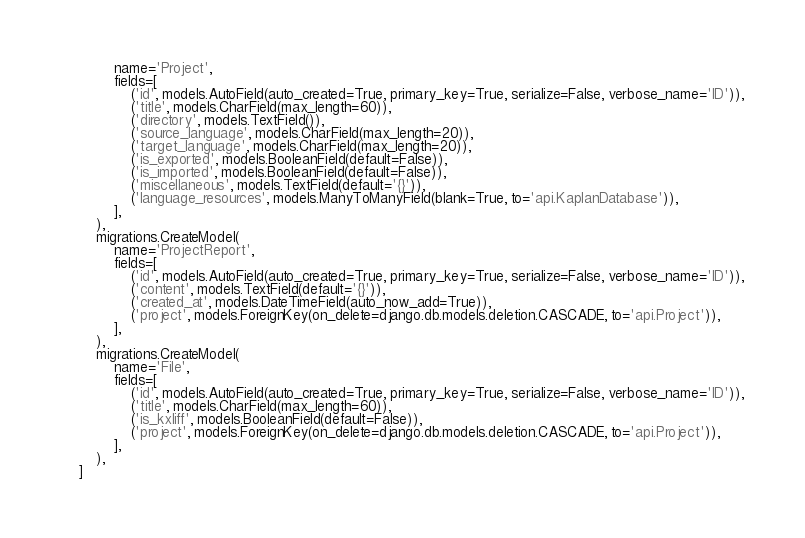<code> <loc_0><loc_0><loc_500><loc_500><_Python_>            name='Project',
            fields=[
                ('id', models.AutoField(auto_created=True, primary_key=True, serialize=False, verbose_name='ID')),
                ('title', models.CharField(max_length=60)),
                ('directory', models.TextField()),
                ('source_language', models.CharField(max_length=20)),
                ('target_language', models.CharField(max_length=20)),
                ('is_exported', models.BooleanField(default=False)),
                ('is_imported', models.BooleanField(default=False)),
                ('miscellaneous', models.TextField(default='{}')),
                ('language_resources', models.ManyToManyField(blank=True, to='api.KaplanDatabase')),
            ],
        ),
        migrations.CreateModel(
            name='ProjectReport',
            fields=[
                ('id', models.AutoField(auto_created=True, primary_key=True, serialize=False, verbose_name='ID')),
                ('content', models.TextField(default='{}')),
                ('created_at', models.DateTimeField(auto_now_add=True)),
                ('project', models.ForeignKey(on_delete=django.db.models.deletion.CASCADE, to='api.Project')),
            ],
        ),
        migrations.CreateModel(
            name='File',
            fields=[
                ('id', models.AutoField(auto_created=True, primary_key=True, serialize=False, verbose_name='ID')),
                ('title', models.CharField(max_length=60)),
                ('is_kxliff', models.BooleanField(default=False)),
                ('project', models.ForeignKey(on_delete=django.db.models.deletion.CASCADE, to='api.Project')),
            ],
        ),
    ]
</code> 